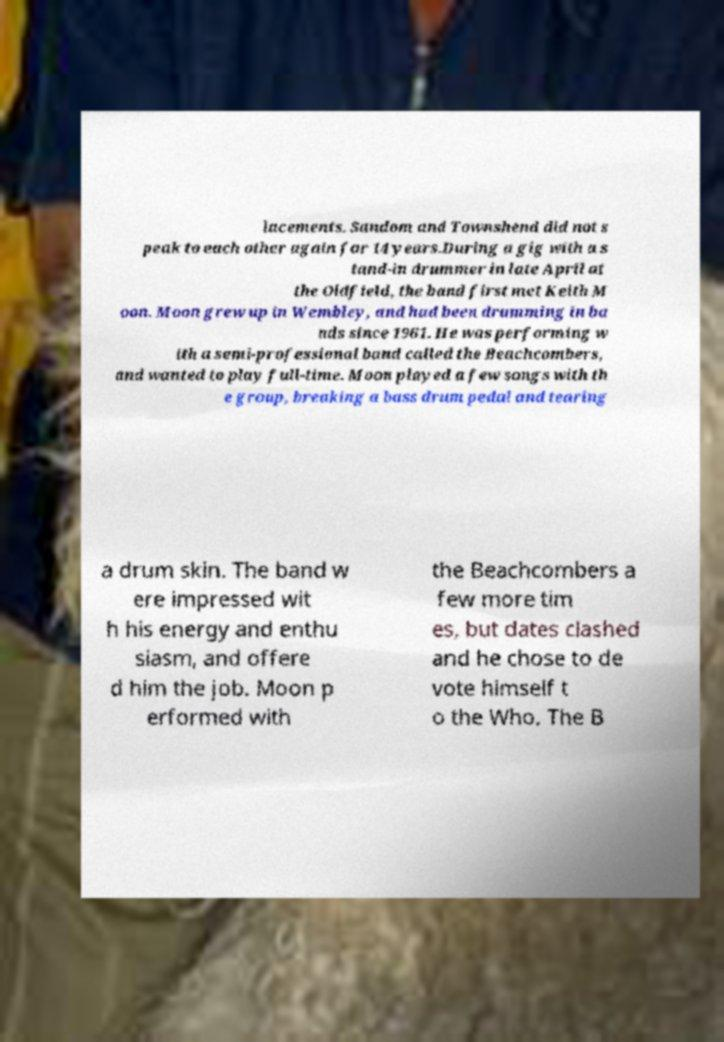Can you accurately transcribe the text from the provided image for me? lacements. Sandom and Townshend did not s peak to each other again for 14 years.During a gig with a s tand-in drummer in late April at the Oldfield, the band first met Keith M oon. Moon grew up in Wembley, and had been drumming in ba nds since 1961. He was performing w ith a semi-professional band called the Beachcombers, and wanted to play full-time. Moon played a few songs with th e group, breaking a bass drum pedal and tearing a drum skin. The band w ere impressed wit h his energy and enthu siasm, and offere d him the job. Moon p erformed with the Beachcombers a few more tim es, but dates clashed and he chose to de vote himself t o the Who. The B 